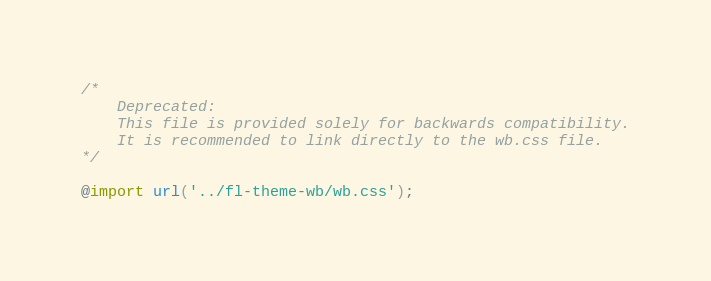<code> <loc_0><loc_0><loc_500><loc_500><_CSS_>/* 
    Deprecated:
    This file is provided solely for backwards compatibility.
    It is recommended to link directly to the wb.css file.
*/

@import url('../fl-theme-wb/wb.css');
</code> 